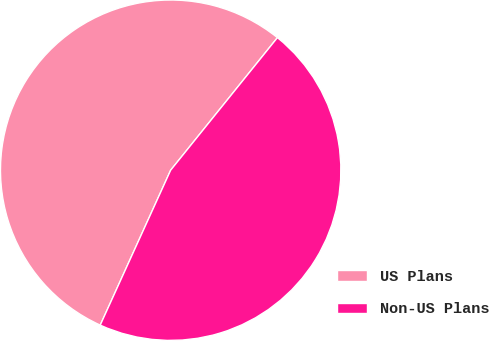Convert chart. <chart><loc_0><loc_0><loc_500><loc_500><pie_chart><fcel>US Plans<fcel>Non-US Plans<nl><fcel>54.0%<fcel>46.0%<nl></chart> 